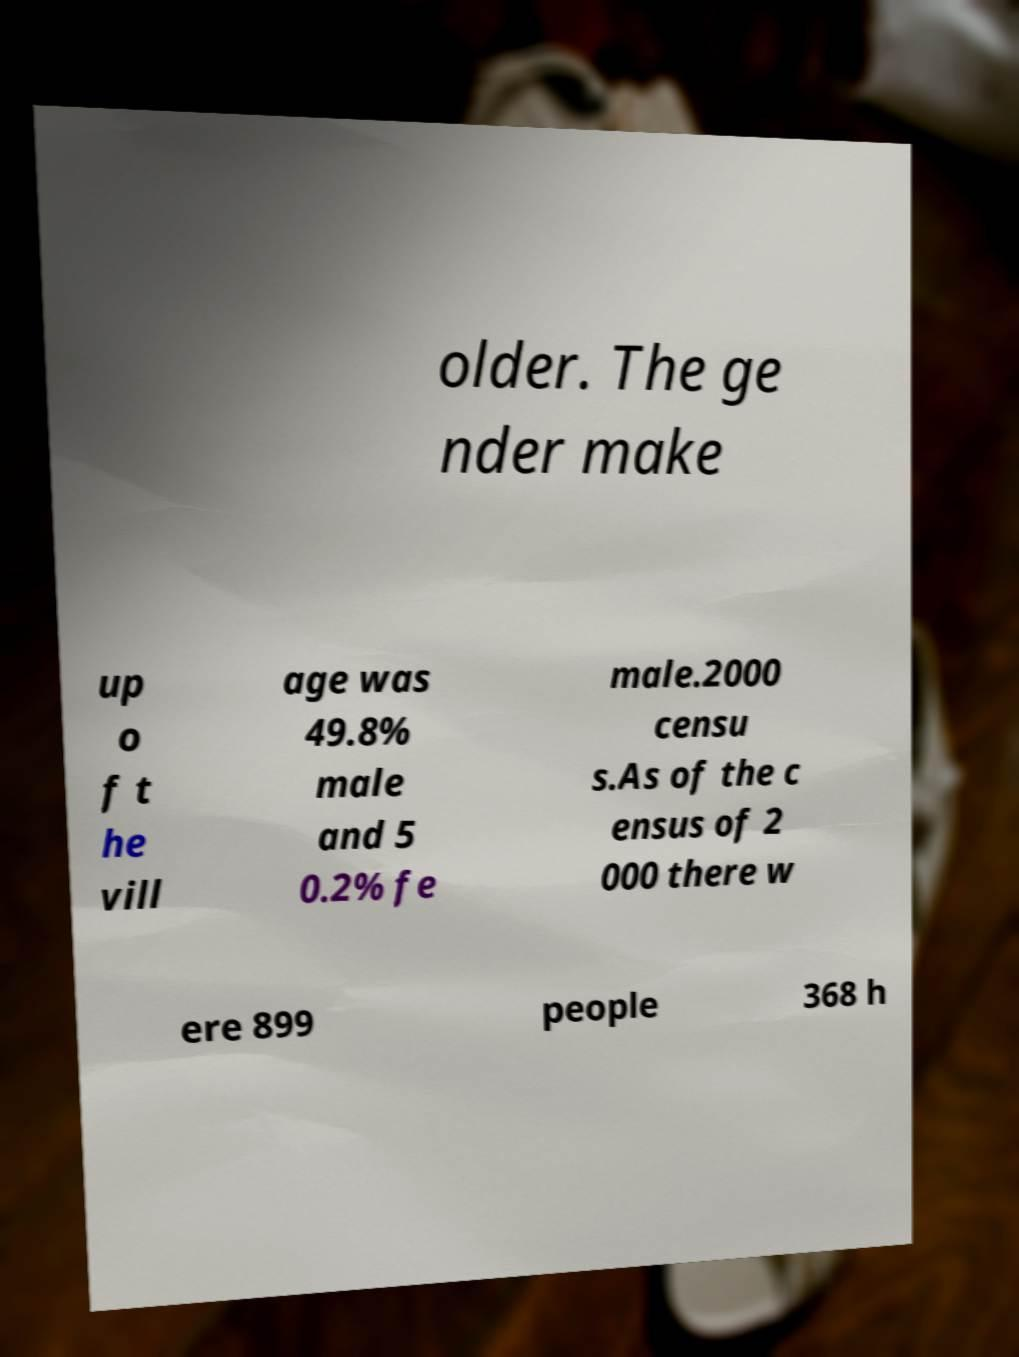For documentation purposes, I need the text within this image transcribed. Could you provide that? older. The ge nder make up o f t he vill age was 49.8% male and 5 0.2% fe male.2000 censu s.As of the c ensus of 2 000 there w ere 899 people 368 h 